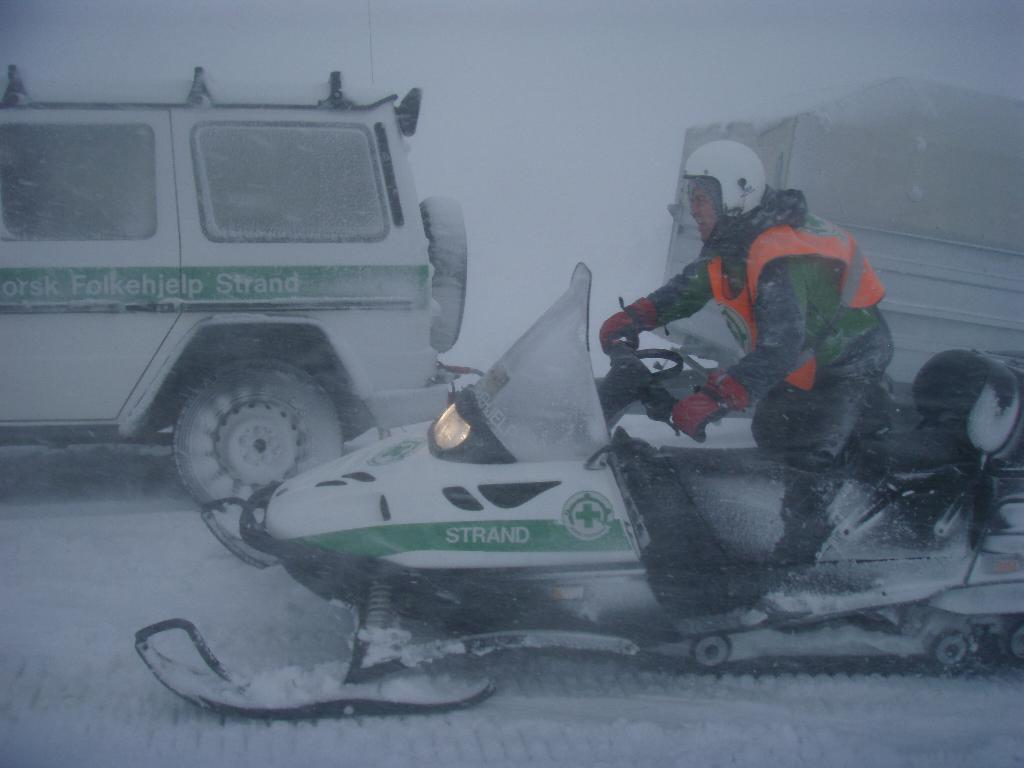What is the man in the image doing? The man is riding a snowmobile in the image. What is the snowmobile on? The snowmobile is on the snow. What else can be seen in the background of the image? There are vehicles visible in the background. What might the white background indicate? The white background likely indicates that there is snow in the area. Where is the man's sister playing basketball in the image? There is no mention of a sister or basketball in the image. 